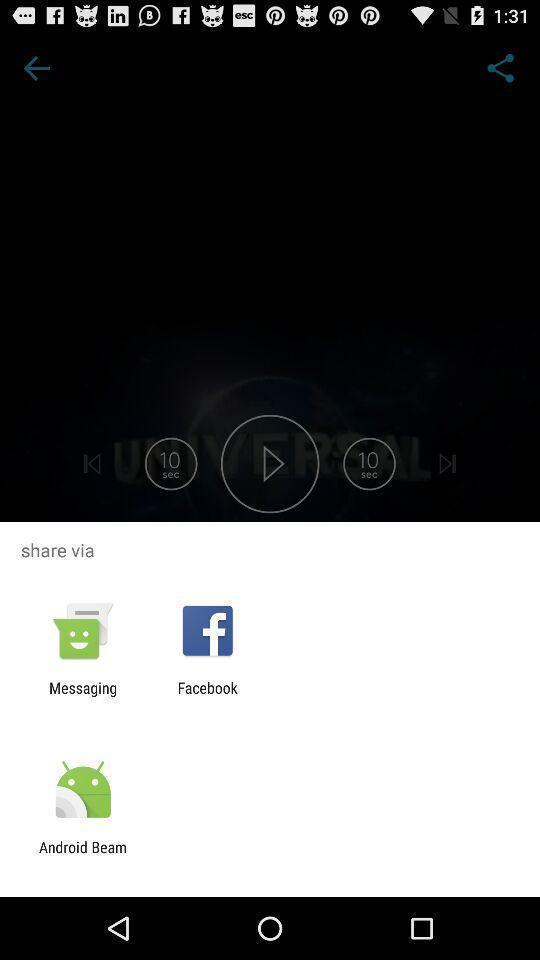Explain the elements present in this screenshot. Push up message for sharing data via social network. 